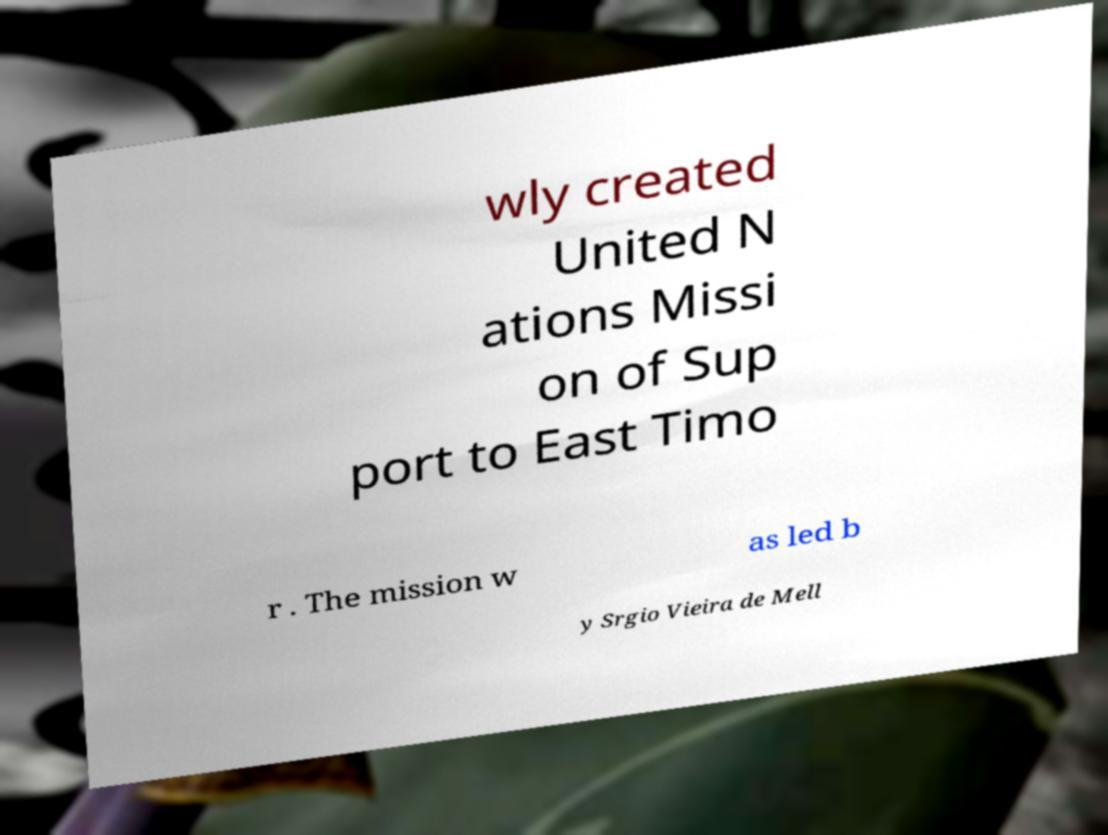Can you read and provide the text displayed in the image?This photo seems to have some interesting text. Can you extract and type it out for me? wly created United N ations Missi on of Sup port to East Timo r . The mission w as led b y Srgio Vieira de Mell 